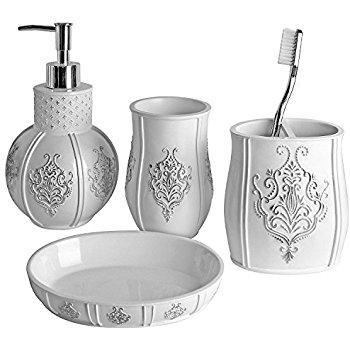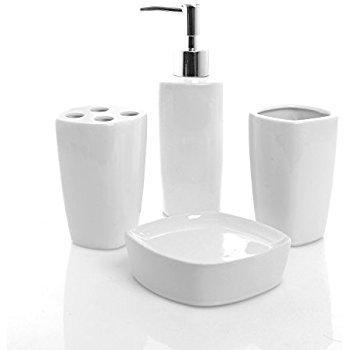The first image is the image on the left, the second image is the image on the right. For the images displayed, is the sentence "The image on the right contains a grouping of four containers with a pump in the center of the back row of three." factually correct? Answer yes or no. Yes. 